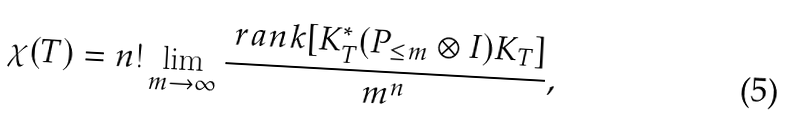<formula> <loc_0><loc_0><loc_500><loc_500>\chi ( T ) = n ! \lim _ { m \to \infty } \frac { \ r a n k [ K _ { T } ^ { * } ( P _ { \leq m } \otimes I ) K _ { T } ] } { m ^ { n } } ,</formula> 